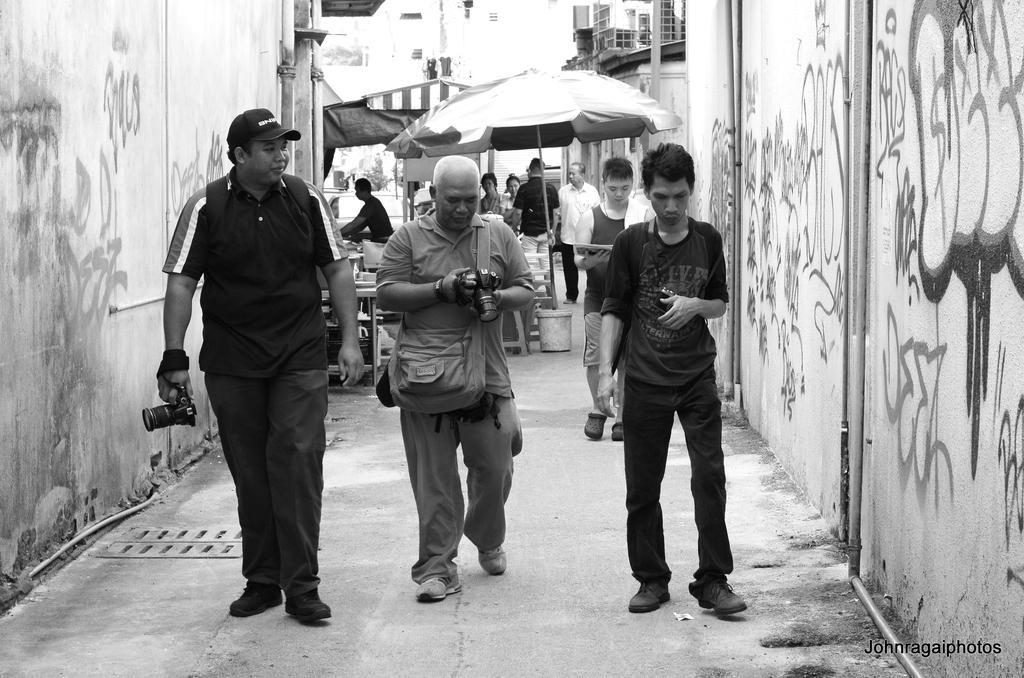Please provide a concise description of this image. It is the black and white image in which there are three persons walking on the floor. In the middle there is a person who is looking into the camera. On the left side there is a person who is walking by holding the camera. In the background there are umbrellas under which there are tables and chairs. Beside the umbrellas there are few people standing on the floor. On the right side there is a wall on which there is painting. 